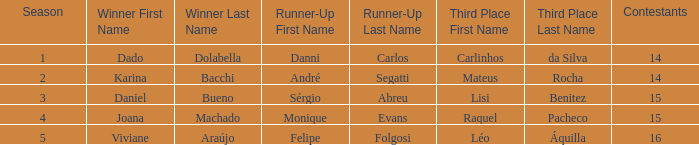In what period was the champion dado dolabella? 1.0. 